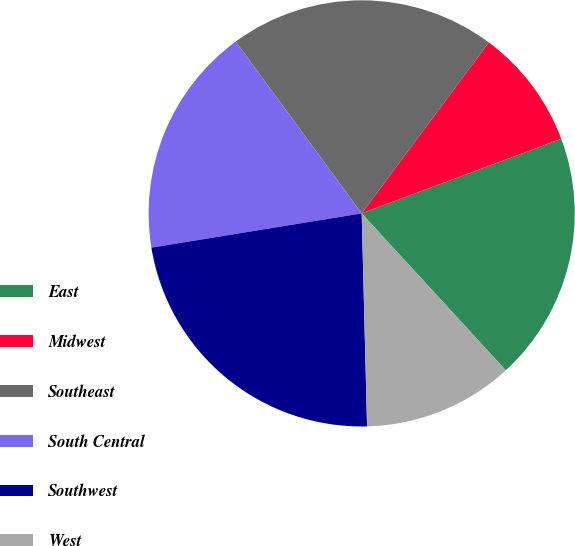Convert chart to OTSL. <chart><loc_0><loc_0><loc_500><loc_500><pie_chart><fcel>East<fcel>Midwest<fcel>Southeast<fcel>South Central<fcel>Southwest<fcel>West<nl><fcel>18.87%<fcel>9.13%<fcel>20.24%<fcel>17.5%<fcel>22.83%<fcel>11.42%<nl></chart> 